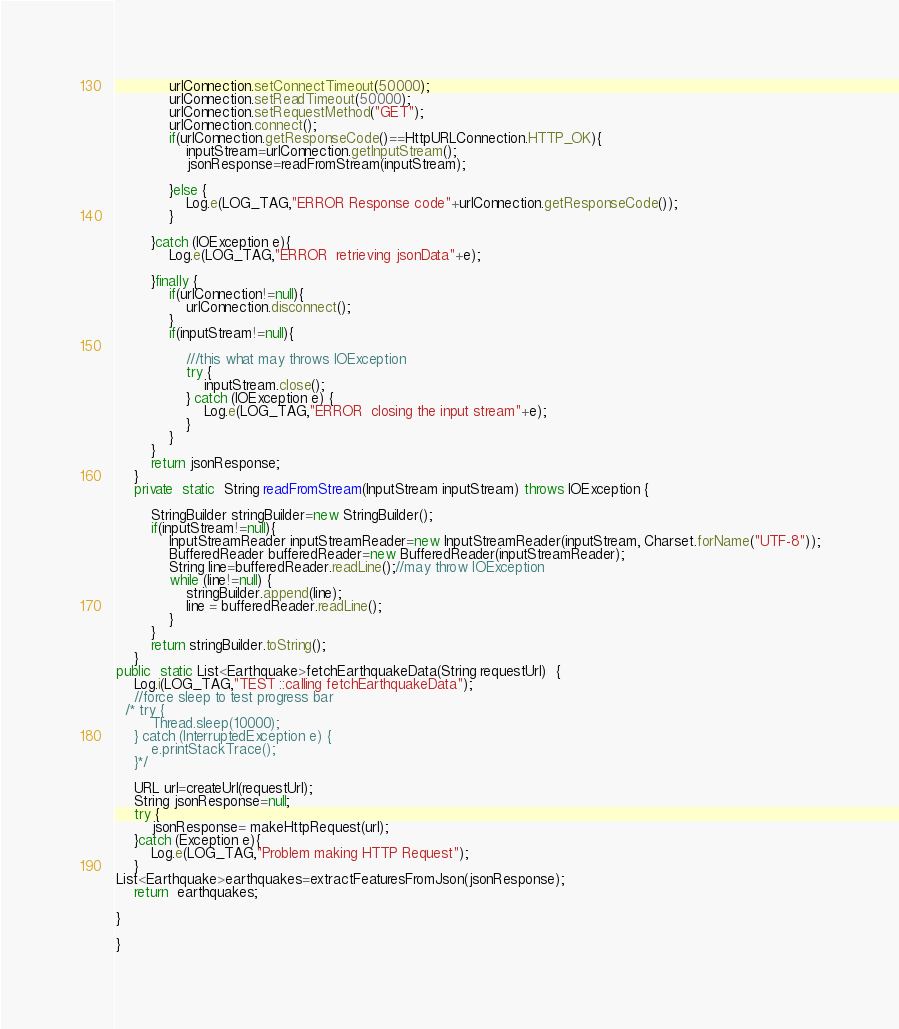Convert code to text. <code><loc_0><loc_0><loc_500><loc_500><_Java_>            urlConnection.setConnectTimeout(50000);
            urlConnection.setReadTimeout(50000);
            urlConnection.setRequestMethod("GET");
            urlConnection.connect();
            if(urlConnection.getResponseCode()==HttpURLConnection.HTTP_OK){
                inputStream=urlConnection.getInputStream();
                jsonResponse=readFromStream(inputStream);

            }else {
                Log.e(LOG_TAG,"ERROR Response code"+urlConnection.getResponseCode());
            }

        }catch (IOException e){
            Log.e(LOG_TAG,"ERROR  retrieving jsonData"+e);

        }finally {
            if(urlConnection!=null){
                urlConnection.disconnect();
            }
            if(inputStream!=null){

                ///this what may throws IOException
                try {
                    inputStream.close();
                } catch (IOException e) {
                    Log.e(LOG_TAG,"ERROR  closing the input stream"+e);
                }
            }
        }
        return jsonResponse;
    }
    private  static  String readFromStream(InputStream inputStream) throws IOException {

        StringBuilder stringBuilder=new StringBuilder();
        if(inputStream!=null){
            InputStreamReader inputStreamReader=new InputStreamReader(inputStream, Charset.forName("UTF-8"));
            BufferedReader bufferedReader=new BufferedReader(inputStreamReader);
            String line=bufferedReader.readLine();//may throw IOException
            while (line!=null) {
                stringBuilder.append(line);
                line = bufferedReader.readLine();
            }
        }
        return stringBuilder.toString();
    }
public  static List<Earthquake>fetchEarthquakeData(String requestUrl)  {
    Log.i(LOG_TAG,"TEST ::calling fetchEarthquakeData");
    //force sleep to test progress bar
  /* try {
        Thread.sleep(10000);
    } catch (InterruptedException e) {
        e.printStackTrace();
    }*/

    URL url=createUrl(requestUrl);
    String jsonResponse=null;
    try {
        jsonResponse= makeHttpRequest(url);
    }catch (Exception e){
        Log.e(LOG_TAG,"Problem making HTTP Request");
    }
List<Earthquake>earthquakes=extractFeaturesFromJson(jsonResponse);
    return  earthquakes;

}

}</code> 